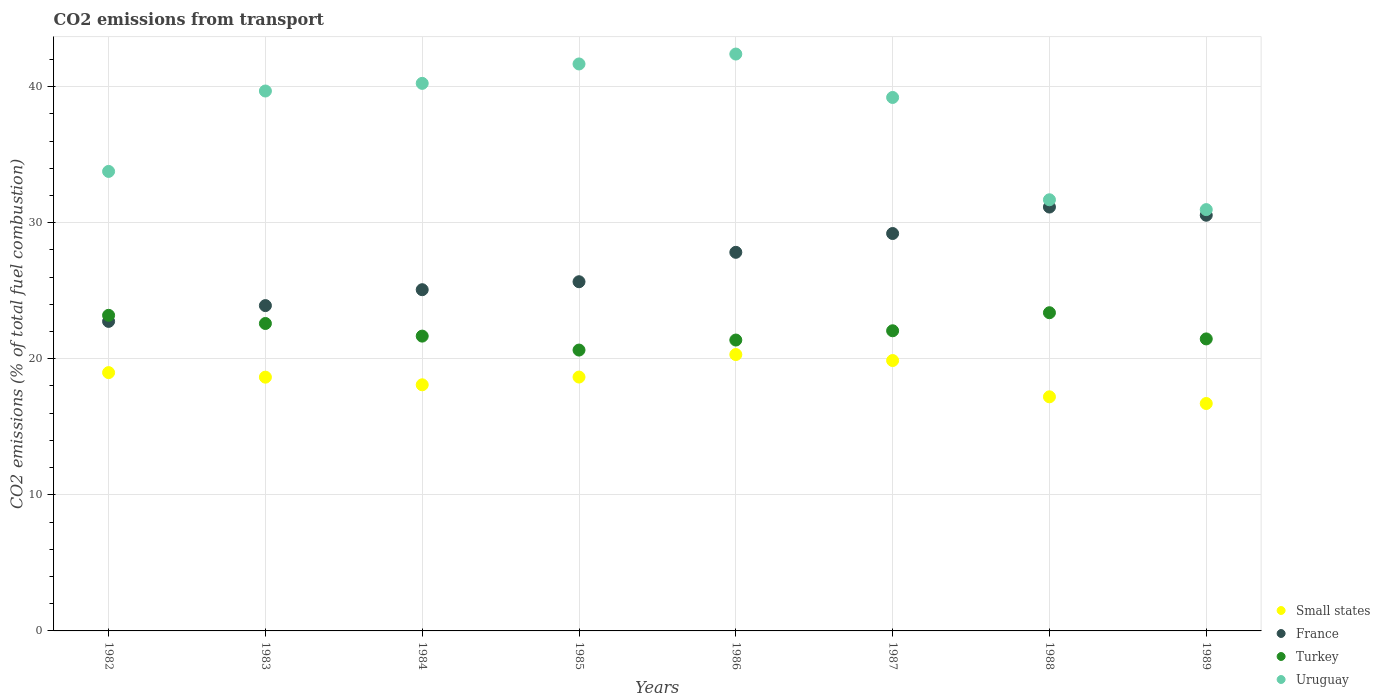Is the number of dotlines equal to the number of legend labels?
Your answer should be very brief. Yes. What is the total CO2 emitted in France in 1985?
Your answer should be compact. 25.66. Across all years, what is the maximum total CO2 emitted in France?
Keep it short and to the point. 31.15. Across all years, what is the minimum total CO2 emitted in Turkey?
Give a very brief answer. 20.64. In which year was the total CO2 emitted in Turkey minimum?
Provide a succinct answer. 1985. What is the total total CO2 emitted in France in the graph?
Your answer should be very brief. 216.12. What is the difference between the total CO2 emitted in Turkey in 1986 and that in 1988?
Make the answer very short. -2.01. What is the difference between the total CO2 emitted in Small states in 1984 and the total CO2 emitted in France in 1982?
Ensure brevity in your answer.  -4.66. What is the average total CO2 emitted in France per year?
Your answer should be compact. 27.02. In the year 1983, what is the difference between the total CO2 emitted in Small states and total CO2 emitted in France?
Offer a very short reply. -5.26. In how many years, is the total CO2 emitted in France greater than 4?
Give a very brief answer. 8. What is the ratio of the total CO2 emitted in France in 1986 to that in 1988?
Give a very brief answer. 0.89. Is the difference between the total CO2 emitted in Small states in 1983 and 1984 greater than the difference between the total CO2 emitted in France in 1983 and 1984?
Your answer should be compact. Yes. What is the difference between the highest and the second highest total CO2 emitted in Uruguay?
Offer a terse response. 0.73. What is the difference between the highest and the lowest total CO2 emitted in Small states?
Offer a terse response. 3.6. Does the total CO2 emitted in Turkey monotonically increase over the years?
Your answer should be very brief. No. Is the total CO2 emitted in Small states strictly greater than the total CO2 emitted in France over the years?
Keep it short and to the point. No. Is the total CO2 emitted in France strictly less than the total CO2 emitted in Turkey over the years?
Keep it short and to the point. No. How many dotlines are there?
Your response must be concise. 4. How many years are there in the graph?
Provide a short and direct response. 8. What is the difference between two consecutive major ticks on the Y-axis?
Provide a succinct answer. 10. Does the graph contain grids?
Make the answer very short. Yes. What is the title of the graph?
Offer a very short reply. CO2 emissions from transport. Does "Finland" appear as one of the legend labels in the graph?
Provide a succinct answer. No. What is the label or title of the X-axis?
Give a very brief answer. Years. What is the label or title of the Y-axis?
Your answer should be compact. CO2 emissions (% of total fuel combustion). What is the CO2 emissions (% of total fuel combustion) in Small states in 1982?
Your response must be concise. 18.98. What is the CO2 emissions (% of total fuel combustion) in France in 1982?
Make the answer very short. 22.75. What is the CO2 emissions (% of total fuel combustion) of Turkey in 1982?
Offer a very short reply. 23.19. What is the CO2 emissions (% of total fuel combustion) in Uruguay in 1982?
Your response must be concise. 33.77. What is the CO2 emissions (% of total fuel combustion) in Small states in 1983?
Ensure brevity in your answer.  18.65. What is the CO2 emissions (% of total fuel combustion) of France in 1983?
Offer a terse response. 23.91. What is the CO2 emissions (% of total fuel combustion) of Turkey in 1983?
Offer a terse response. 22.59. What is the CO2 emissions (% of total fuel combustion) of Uruguay in 1983?
Your response must be concise. 39.68. What is the CO2 emissions (% of total fuel combustion) in Small states in 1984?
Keep it short and to the point. 18.09. What is the CO2 emissions (% of total fuel combustion) in France in 1984?
Offer a very short reply. 25.08. What is the CO2 emissions (% of total fuel combustion) in Turkey in 1984?
Your response must be concise. 21.67. What is the CO2 emissions (% of total fuel combustion) of Uruguay in 1984?
Provide a succinct answer. 40.24. What is the CO2 emissions (% of total fuel combustion) of Small states in 1985?
Provide a short and direct response. 18.66. What is the CO2 emissions (% of total fuel combustion) of France in 1985?
Give a very brief answer. 25.66. What is the CO2 emissions (% of total fuel combustion) in Turkey in 1985?
Give a very brief answer. 20.64. What is the CO2 emissions (% of total fuel combustion) of Uruguay in 1985?
Your answer should be compact. 41.67. What is the CO2 emissions (% of total fuel combustion) of Small states in 1986?
Keep it short and to the point. 20.31. What is the CO2 emissions (% of total fuel combustion) in France in 1986?
Provide a short and direct response. 27.82. What is the CO2 emissions (% of total fuel combustion) in Turkey in 1986?
Offer a very short reply. 21.38. What is the CO2 emissions (% of total fuel combustion) of Uruguay in 1986?
Offer a terse response. 42.39. What is the CO2 emissions (% of total fuel combustion) in Small states in 1987?
Make the answer very short. 19.87. What is the CO2 emissions (% of total fuel combustion) in France in 1987?
Provide a succinct answer. 29.21. What is the CO2 emissions (% of total fuel combustion) in Turkey in 1987?
Make the answer very short. 22.06. What is the CO2 emissions (% of total fuel combustion) of Uruguay in 1987?
Give a very brief answer. 39.2. What is the CO2 emissions (% of total fuel combustion) of Small states in 1988?
Offer a terse response. 17.2. What is the CO2 emissions (% of total fuel combustion) of France in 1988?
Offer a very short reply. 31.15. What is the CO2 emissions (% of total fuel combustion) of Turkey in 1988?
Provide a short and direct response. 23.38. What is the CO2 emissions (% of total fuel combustion) in Uruguay in 1988?
Make the answer very short. 31.69. What is the CO2 emissions (% of total fuel combustion) in Small states in 1989?
Offer a very short reply. 16.71. What is the CO2 emissions (% of total fuel combustion) in France in 1989?
Your answer should be very brief. 30.55. What is the CO2 emissions (% of total fuel combustion) of Turkey in 1989?
Give a very brief answer. 21.46. What is the CO2 emissions (% of total fuel combustion) of Uruguay in 1989?
Give a very brief answer. 30.96. Across all years, what is the maximum CO2 emissions (% of total fuel combustion) of Small states?
Give a very brief answer. 20.31. Across all years, what is the maximum CO2 emissions (% of total fuel combustion) in France?
Your answer should be compact. 31.15. Across all years, what is the maximum CO2 emissions (% of total fuel combustion) of Turkey?
Provide a short and direct response. 23.38. Across all years, what is the maximum CO2 emissions (% of total fuel combustion) of Uruguay?
Give a very brief answer. 42.39. Across all years, what is the minimum CO2 emissions (% of total fuel combustion) of Small states?
Provide a short and direct response. 16.71. Across all years, what is the minimum CO2 emissions (% of total fuel combustion) of France?
Ensure brevity in your answer.  22.75. Across all years, what is the minimum CO2 emissions (% of total fuel combustion) of Turkey?
Your answer should be very brief. 20.64. Across all years, what is the minimum CO2 emissions (% of total fuel combustion) in Uruguay?
Keep it short and to the point. 30.96. What is the total CO2 emissions (% of total fuel combustion) of Small states in the graph?
Make the answer very short. 148.47. What is the total CO2 emissions (% of total fuel combustion) in France in the graph?
Ensure brevity in your answer.  216.12. What is the total CO2 emissions (% of total fuel combustion) in Turkey in the graph?
Make the answer very short. 176.37. What is the total CO2 emissions (% of total fuel combustion) of Uruguay in the graph?
Keep it short and to the point. 299.6. What is the difference between the CO2 emissions (% of total fuel combustion) of Small states in 1982 and that in 1983?
Your answer should be very brief. 0.33. What is the difference between the CO2 emissions (% of total fuel combustion) in France in 1982 and that in 1983?
Offer a very short reply. -1.16. What is the difference between the CO2 emissions (% of total fuel combustion) of Turkey in 1982 and that in 1983?
Give a very brief answer. 0.6. What is the difference between the CO2 emissions (% of total fuel combustion) in Uruguay in 1982 and that in 1983?
Offer a terse response. -5.91. What is the difference between the CO2 emissions (% of total fuel combustion) in Small states in 1982 and that in 1984?
Your answer should be compact. 0.9. What is the difference between the CO2 emissions (% of total fuel combustion) of France in 1982 and that in 1984?
Provide a short and direct response. -2.33. What is the difference between the CO2 emissions (% of total fuel combustion) in Turkey in 1982 and that in 1984?
Offer a very short reply. 1.53. What is the difference between the CO2 emissions (% of total fuel combustion) of Uruguay in 1982 and that in 1984?
Your answer should be very brief. -6.47. What is the difference between the CO2 emissions (% of total fuel combustion) in Small states in 1982 and that in 1985?
Provide a succinct answer. 0.33. What is the difference between the CO2 emissions (% of total fuel combustion) of France in 1982 and that in 1985?
Your answer should be compact. -2.91. What is the difference between the CO2 emissions (% of total fuel combustion) in Turkey in 1982 and that in 1985?
Keep it short and to the point. 2.55. What is the difference between the CO2 emissions (% of total fuel combustion) in Uruguay in 1982 and that in 1985?
Your answer should be compact. -7.9. What is the difference between the CO2 emissions (% of total fuel combustion) of Small states in 1982 and that in 1986?
Provide a short and direct response. -1.33. What is the difference between the CO2 emissions (% of total fuel combustion) in France in 1982 and that in 1986?
Provide a succinct answer. -5.08. What is the difference between the CO2 emissions (% of total fuel combustion) in Turkey in 1982 and that in 1986?
Your response must be concise. 1.82. What is the difference between the CO2 emissions (% of total fuel combustion) of Uruguay in 1982 and that in 1986?
Your answer should be compact. -8.63. What is the difference between the CO2 emissions (% of total fuel combustion) of Small states in 1982 and that in 1987?
Your answer should be very brief. -0.89. What is the difference between the CO2 emissions (% of total fuel combustion) of France in 1982 and that in 1987?
Give a very brief answer. -6.46. What is the difference between the CO2 emissions (% of total fuel combustion) of Turkey in 1982 and that in 1987?
Provide a short and direct response. 1.14. What is the difference between the CO2 emissions (% of total fuel combustion) in Uruguay in 1982 and that in 1987?
Your answer should be compact. -5.44. What is the difference between the CO2 emissions (% of total fuel combustion) in Small states in 1982 and that in 1988?
Keep it short and to the point. 1.78. What is the difference between the CO2 emissions (% of total fuel combustion) in France in 1982 and that in 1988?
Provide a succinct answer. -8.4. What is the difference between the CO2 emissions (% of total fuel combustion) of Turkey in 1982 and that in 1988?
Your answer should be compact. -0.19. What is the difference between the CO2 emissions (% of total fuel combustion) in Uruguay in 1982 and that in 1988?
Provide a short and direct response. 2.08. What is the difference between the CO2 emissions (% of total fuel combustion) of Small states in 1982 and that in 1989?
Keep it short and to the point. 2.27. What is the difference between the CO2 emissions (% of total fuel combustion) in France in 1982 and that in 1989?
Offer a very short reply. -7.8. What is the difference between the CO2 emissions (% of total fuel combustion) of Turkey in 1982 and that in 1989?
Provide a succinct answer. 1.73. What is the difference between the CO2 emissions (% of total fuel combustion) of Uruguay in 1982 and that in 1989?
Your response must be concise. 2.81. What is the difference between the CO2 emissions (% of total fuel combustion) in Small states in 1983 and that in 1984?
Provide a short and direct response. 0.56. What is the difference between the CO2 emissions (% of total fuel combustion) in France in 1983 and that in 1984?
Keep it short and to the point. -1.17. What is the difference between the CO2 emissions (% of total fuel combustion) of Turkey in 1983 and that in 1984?
Offer a very short reply. 0.93. What is the difference between the CO2 emissions (% of total fuel combustion) in Uruguay in 1983 and that in 1984?
Provide a succinct answer. -0.56. What is the difference between the CO2 emissions (% of total fuel combustion) in Small states in 1983 and that in 1985?
Offer a terse response. -0.01. What is the difference between the CO2 emissions (% of total fuel combustion) of France in 1983 and that in 1985?
Make the answer very short. -1.75. What is the difference between the CO2 emissions (% of total fuel combustion) of Turkey in 1983 and that in 1985?
Provide a succinct answer. 1.95. What is the difference between the CO2 emissions (% of total fuel combustion) in Uruguay in 1983 and that in 1985?
Your answer should be compact. -1.99. What is the difference between the CO2 emissions (% of total fuel combustion) in Small states in 1983 and that in 1986?
Offer a very short reply. -1.66. What is the difference between the CO2 emissions (% of total fuel combustion) of France in 1983 and that in 1986?
Keep it short and to the point. -3.92. What is the difference between the CO2 emissions (% of total fuel combustion) in Turkey in 1983 and that in 1986?
Ensure brevity in your answer.  1.22. What is the difference between the CO2 emissions (% of total fuel combustion) of Uruguay in 1983 and that in 1986?
Provide a succinct answer. -2.72. What is the difference between the CO2 emissions (% of total fuel combustion) in Small states in 1983 and that in 1987?
Your answer should be compact. -1.22. What is the difference between the CO2 emissions (% of total fuel combustion) in France in 1983 and that in 1987?
Keep it short and to the point. -5.3. What is the difference between the CO2 emissions (% of total fuel combustion) of Turkey in 1983 and that in 1987?
Make the answer very short. 0.54. What is the difference between the CO2 emissions (% of total fuel combustion) of Uruguay in 1983 and that in 1987?
Your answer should be compact. 0.47. What is the difference between the CO2 emissions (% of total fuel combustion) of Small states in 1983 and that in 1988?
Ensure brevity in your answer.  1.44. What is the difference between the CO2 emissions (% of total fuel combustion) of France in 1983 and that in 1988?
Give a very brief answer. -7.24. What is the difference between the CO2 emissions (% of total fuel combustion) of Turkey in 1983 and that in 1988?
Your response must be concise. -0.79. What is the difference between the CO2 emissions (% of total fuel combustion) in Uruguay in 1983 and that in 1988?
Provide a short and direct response. 7.99. What is the difference between the CO2 emissions (% of total fuel combustion) of Small states in 1983 and that in 1989?
Your answer should be very brief. 1.94. What is the difference between the CO2 emissions (% of total fuel combustion) of France in 1983 and that in 1989?
Provide a short and direct response. -6.64. What is the difference between the CO2 emissions (% of total fuel combustion) of Turkey in 1983 and that in 1989?
Give a very brief answer. 1.13. What is the difference between the CO2 emissions (% of total fuel combustion) in Uruguay in 1983 and that in 1989?
Offer a very short reply. 8.72. What is the difference between the CO2 emissions (% of total fuel combustion) of Small states in 1984 and that in 1985?
Provide a short and direct response. -0.57. What is the difference between the CO2 emissions (% of total fuel combustion) of France in 1984 and that in 1985?
Keep it short and to the point. -0.59. What is the difference between the CO2 emissions (% of total fuel combustion) in Turkey in 1984 and that in 1985?
Provide a short and direct response. 1.03. What is the difference between the CO2 emissions (% of total fuel combustion) of Uruguay in 1984 and that in 1985?
Ensure brevity in your answer.  -1.43. What is the difference between the CO2 emissions (% of total fuel combustion) in Small states in 1984 and that in 1986?
Your answer should be very brief. -2.22. What is the difference between the CO2 emissions (% of total fuel combustion) in France in 1984 and that in 1986?
Your answer should be very brief. -2.75. What is the difference between the CO2 emissions (% of total fuel combustion) of Turkey in 1984 and that in 1986?
Ensure brevity in your answer.  0.29. What is the difference between the CO2 emissions (% of total fuel combustion) in Uruguay in 1984 and that in 1986?
Offer a very short reply. -2.15. What is the difference between the CO2 emissions (% of total fuel combustion) in Small states in 1984 and that in 1987?
Offer a terse response. -1.78. What is the difference between the CO2 emissions (% of total fuel combustion) in France in 1984 and that in 1987?
Your answer should be very brief. -4.13. What is the difference between the CO2 emissions (% of total fuel combustion) in Turkey in 1984 and that in 1987?
Provide a succinct answer. -0.39. What is the difference between the CO2 emissions (% of total fuel combustion) in Uruguay in 1984 and that in 1987?
Provide a short and direct response. 1.04. What is the difference between the CO2 emissions (% of total fuel combustion) of Small states in 1984 and that in 1988?
Keep it short and to the point. 0.88. What is the difference between the CO2 emissions (% of total fuel combustion) of France in 1984 and that in 1988?
Offer a terse response. -6.07. What is the difference between the CO2 emissions (% of total fuel combustion) in Turkey in 1984 and that in 1988?
Offer a terse response. -1.72. What is the difference between the CO2 emissions (% of total fuel combustion) in Uruguay in 1984 and that in 1988?
Your answer should be very brief. 8.55. What is the difference between the CO2 emissions (% of total fuel combustion) of Small states in 1984 and that in 1989?
Your answer should be compact. 1.37. What is the difference between the CO2 emissions (% of total fuel combustion) of France in 1984 and that in 1989?
Give a very brief answer. -5.47. What is the difference between the CO2 emissions (% of total fuel combustion) of Turkey in 1984 and that in 1989?
Keep it short and to the point. 0.21. What is the difference between the CO2 emissions (% of total fuel combustion) in Uruguay in 1984 and that in 1989?
Your answer should be very brief. 9.28. What is the difference between the CO2 emissions (% of total fuel combustion) of Small states in 1985 and that in 1986?
Your response must be concise. -1.65. What is the difference between the CO2 emissions (% of total fuel combustion) of France in 1985 and that in 1986?
Provide a short and direct response. -2.16. What is the difference between the CO2 emissions (% of total fuel combustion) of Turkey in 1985 and that in 1986?
Ensure brevity in your answer.  -0.74. What is the difference between the CO2 emissions (% of total fuel combustion) of Uruguay in 1985 and that in 1986?
Your answer should be very brief. -0.73. What is the difference between the CO2 emissions (% of total fuel combustion) of Small states in 1985 and that in 1987?
Ensure brevity in your answer.  -1.21. What is the difference between the CO2 emissions (% of total fuel combustion) of France in 1985 and that in 1987?
Provide a succinct answer. -3.54. What is the difference between the CO2 emissions (% of total fuel combustion) in Turkey in 1985 and that in 1987?
Ensure brevity in your answer.  -1.42. What is the difference between the CO2 emissions (% of total fuel combustion) in Uruguay in 1985 and that in 1987?
Give a very brief answer. 2.46. What is the difference between the CO2 emissions (% of total fuel combustion) of Small states in 1985 and that in 1988?
Give a very brief answer. 1.45. What is the difference between the CO2 emissions (% of total fuel combustion) of France in 1985 and that in 1988?
Provide a succinct answer. -5.49. What is the difference between the CO2 emissions (% of total fuel combustion) in Turkey in 1985 and that in 1988?
Provide a succinct answer. -2.74. What is the difference between the CO2 emissions (% of total fuel combustion) of Uruguay in 1985 and that in 1988?
Offer a very short reply. 9.98. What is the difference between the CO2 emissions (% of total fuel combustion) in Small states in 1985 and that in 1989?
Give a very brief answer. 1.94. What is the difference between the CO2 emissions (% of total fuel combustion) of France in 1985 and that in 1989?
Give a very brief answer. -4.89. What is the difference between the CO2 emissions (% of total fuel combustion) of Turkey in 1985 and that in 1989?
Keep it short and to the point. -0.82. What is the difference between the CO2 emissions (% of total fuel combustion) in Uruguay in 1985 and that in 1989?
Ensure brevity in your answer.  10.7. What is the difference between the CO2 emissions (% of total fuel combustion) in Small states in 1986 and that in 1987?
Your answer should be very brief. 0.44. What is the difference between the CO2 emissions (% of total fuel combustion) of France in 1986 and that in 1987?
Ensure brevity in your answer.  -1.38. What is the difference between the CO2 emissions (% of total fuel combustion) of Turkey in 1986 and that in 1987?
Provide a succinct answer. -0.68. What is the difference between the CO2 emissions (% of total fuel combustion) in Uruguay in 1986 and that in 1987?
Provide a short and direct response. 3.19. What is the difference between the CO2 emissions (% of total fuel combustion) in Small states in 1986 and that in 1988?
Offer a terse response. 3.11. What is the difference between the CO2 emissions (% of total fuel combustion) of France in 1986 and that in 1988?
Your response must be concise. -3.33. What is the difference between the CO2 emissions (% of total fuel combustion) of Turkey in 1986 and that in 1988?
Keep it short and to the point. -2.01. What is the difference between the CO2 emissions (% of total fuel combustion) in Uruguay in 1986 and that in 1988?
Ensure brevity in your answer.  10.71. What is the difference between the CO2 emissions (% of total fuel combustion) in Small states in 1986 and that in 1989?
Ensure brevity in your answer.  3.6. What is the difference between the CO2 emissions (% of total fuel combustion) in France in 1986 and that in 1989?
Your response must be concise. -2.73. What is the difference between the CO2 emissions (% of total fuel combustion) in Turkey in 1986 and that in 1989?
Offer a very short reply. -0.08. What is the difference between the CO2 emissions (% of total fuel combustion) of Uruguay in 1986 and that in 1989?
Your answer should be compact. 11.43. What is the difference between the CO2 emissions (% of total fuel combustion) in Small states in 1987 and that in 1988?
Keep it short and to the point. 2.67. What is the difference between the CO2 emissions (% of total fuel combustion) of France in 1987 and that in 1988?
Keep it short and to the point. -1.94. What is the difference between the CO2 emissions (% of total fuel combustion) in Turkey in 1987 and that in 1988?
Provide a succinct answer. -1.33. What is the difference between the CO2 emissions (% of total fuel combustion) of Uruguay in 1987 and that in 1988?
Offer a very short reply. 7.52. What is the difference between the CO2 emissions (% of total fuel combustion) of Small states in 1987 and that in 1989?
Your response must be concise. 3.16. What is the difference between the CO2 emissions (% of total fuel combustion) in France in 1987 and that in 1989?
Offer a terse response. -1.34. What is the difference between the CO2 emissions (% of total fuel combustion) in Turkey in 1987 and that in 1989?
Offer a terse response. 0.6. What is the difference between the CO2 emissions (% of total fuel combustion) of Uruguay in 1987 and that in 1989?
Ensure brevity in your answer.  8.24. What is the difference between the CO2 emissions (% of total fuel combustion) in Small states in 1988 and that in 1989?
Offer a very short reply. 0.49. What is the difference between the CO2 emissions (% of total fuel combustion) of France in 1988 and that in 1989?
Offer a very short reply. 0.6. What is the difference between the CO2 emissions (% of total fuel combustion) of Turkey in 1988 and that in 1989?
Ensure brevity in your answer.  1.92. What is the difference between the CO2 emissions (% of total fuel combustion) of Uruguay in 1988 and that in 1989?
Provide a succinct answer. 0.72. What is the difference between the CO2 emissions (% of total fuel combustion) in Small states in 1982 and the CO2 emissions (% of total fuel combustion) in France in 1983?
Your answer should be very brief. -4.92. What is the difference between the CO2 emissions (% of total fuel combustion) in Small states in 1982 and the CO2 emissions (% of total fuel combustion) in Turkey in 1983?
Give a very brief answer. -3.61. What is the difference between the CO2 emissions (% of total fuel combustion) in Small states in 1982 and the CO2 emissions (% of total fuel combustion) in Uruguay in 1983?
Provide a succinct answer. -20.7. What is the difference between the CO2 emissions (% of total fuel combustion) of France in 1982 and the CO2 emissions (% of total fuel combustion) of Turkey in 1983?
Make the answer very short. 0.15. What is the difference between the CO2 emissions (% of total fuel combustion) in France in 1982 and the CO2 emissions (% of total fuel combustion) in Uruguay in 1983?
Make the answer very short. -16.93. What is the difference between the CO2 emissions (% of total fuel combustion) of Turkey in 1982 and the CO2 emissions (% of total fuel combustion) of Uruguay in 1983?
Your response must be concise. -16.48. What is the difference between the CO2 emissions (% of total fuel combustion) of Small states in 1982 and the CO2 emissions (% of total fuel combustion) of France in 1984?
Provide a succinct answer. -6.09. What is the difference between the CO2 emissions (% of total fuel combustion) of Small states in 1982 and the CO2 emissions (% of total fuel combustion) of Turkey in 1984?
Your answer should be compact. -2.68. What is the difference between the CO2 emissions (% of total fuel combustion) in Small states in 1982 and the CO2 emissions (% of total fuel combustion) in Uruguay in 1984?
Provide a succinct answer. -21.26. What is the difference between the CO2 emissions (% of total fuel combustion) of France in 1982 and the CO2 emissions (% of total fuel combustion) of Turkey in 1984?
Your response must be concise. 1.08. What is the difference between the CO2 emissions (% of total fuel combustion) in France in 1982 and the CO2 emissions (% of total fuel combustion) in Uruguay in 1984?
Offer a very short reply. -17.49. What is the difference between the CO2 emissions (% of total fuel combustion) of Turkey in 1982 and the CO2 emissions (% of total fuel combustion) of Uruguay in 1984?
Ensure brevity in your answer.  -17.05. What is the difference between the CO2 emissions (% of total fuel combustion) of Small states in 1982 and the CO2 emissions (% of total fuel combustion) of France in 1985?
Your answer should be compact. -6.68. What is the difference between the CO2 emissions (% of total fuel combustion) in Small states in 1982 and the CO2 emissions (% of total fuel combustion) in Turkey in 1985?
Your response must be concise. -1.66. What is the difference between the CO2 emissions (% of total fuel combustion) in Small states in 1982 and the CO2 emissions (% of total fuel combustion) in Uruguay in 1985?
Offer a terse response. -22.68. What is the difference between the CO2 emissions (% of total fuel combustion) of France in 1982 and the CO2 emissions (% of total fuel combustion) of Turkey in 1985?
Your answer should be very brief. 2.11. What is the difference between the CO2 emissions (% of total fuel combustion) in France in 1982 and the CO2 emissions (% of total fuel combustion) in Uruguay in 1985?
Keep it short and to the point. -18.92. What is the difference between the CO2 emissions (% of total fuel combustion) of Turkey in 1982 and the CO2 emissions (% of total fuel combustion) of Uruguay in 1985?
Offer a terse response. -18.47. What is the difference between the CO2 emissions (% of total fuel combustion) in Small states in 1982 and the CO2 emissions (% of total fuel combustion) in France in 1986?
Ensure brevity in your answer.  -8.84. What is the difference between the CO2 emissions (% of total fuel combustion) in Small states in 1982 and the CO2 emissions (% of total fuel combustion) in Turkey in 1986?
Make the answer very short. -2.39. What is the difference between the CO2 emissions (% of total fuel combustion) in Small states in 1982 and the CO2 emissions (% of total fuel combustion) in Uruguay in 1986?
Keep it short and to the point. -23.41. What is the difference between the CO2 emissions (% of total fuel combustion) in France in 1982 and the CO2 emissions (% of total fuel combustion) in Turkey in 1986?
Your answer should be very brief. 1.37. What is the difference between the CO2 emissions (% of total fuel combustion) of France in 1982 and the CO2 emissions (% of total fuel combustion) of Uruguay in 1986?
Provide a short and direct response. -19.65. What is the difference between the CO2 emissions (% of total fuel combustion) of Turkey in 1982 and the CO2 emissions (% of total fuel combustion) of Uruguay in 1986?
Give a very brief answer. -19.2. What is the difference between the CO2 emissions (% of total fuel combustion) of Small states in 1982 and the CO2 emissions (% of total fuel combustion) of France in 1987?
Offer a very short reply. -10.22. What is the difference between the CO2 emissions (% of total fuel combustion) of Small states in 1982 and the CO2 emissions (% of total fuel combustion) of Turkey in 1987?
Provide a succinct answer. -3.07. What is the difference between the CO2 emissions (% of total fuel combustion) of Small states in 1982 and the CO2 emissions (% of total fuel combustion) of Uruguay in 1987?
Keep it short and to the point. -20.22. What is the difference between the CO2 emissions (% of total fuel combustion) in France in 1982 and the CO2 emissions (% of total fuel combustion) in Turkey in 1987?
Your answer should be compact. 0.69. What is the difference between the CO2 emissions (% of total fuel combustion) in France in 1982 and the CO2 emissions (% of total fuel combustion) in Uruguay in 1987?
Ensure brevity in your answer.  -16.46. What is the difference between the CO2 emissions (% of total fuel combustion) of Turkey in 1982 and the CO2 emissions (% of total fuel combustion) of Uruguay in 1987?
Ensure brevity in your answer.  -16.01. What is the difference between the CO2 emissions (% of total fuel combustion) in Small states in 1982 and the CO2 emissions (% of total fuel combustion) in France in 1988?
Give a very brief answer. -12.17. What is the difference between the CO2 emissions (% of total fuel combustion) in Small states in 1982 and the CO2 emissions (% of total fuel combustion) in Turkey in 1988?
Provide a short and direct response. -4.4. What is the difference between the CO2 emissions (% of total fuel combustion) of Small states in 1982 and the CO2 emissions (% of total fuel combustion) of Uruguay in 1988?
Ensure brevity in your answer.  -12.7. What is the difference between the CO2 emissions (% of total fuel combustion) of France in 1982 and the CO2 emissions (% of total fuel combustion) of Turkey in 1988?
Your answer should be compact. -0.64. What is the difference between the CO2 emissions (% of total fuel combustion) of France in 1982 and the CO2 emissions (% of total fuel combustion) of Uruguay in 1988?
Offer a terse response. -8.94. What is the difference between the CO2 emissions (% of total fuel combustion) in Turkey in 1982 and the CO2 emissions (% of total fuel combustion) in Uruguay in 1988?
Offer a terse response. -8.49. What is the difference between the CO2 emissions (% of total fuel combustion) in Small states in 1982 and the CO2 emissions (% of total fuel combustion) in France in 1989?
Your answer should be compact. -11.57. What is the difference between the CO2 emissions (% of total fuel combustion) in Small states in 1982 and the CO2 emissions (% of total fuel combustion) in Turkey in 1989?
Provide a succinct answer. -2.48. What is the difference between the CO2 emissions (% of total fuel combustion) of Small states in 1982 and the CO2 emissions (% of total fuel combustion) of Uruguay in 1989?
Offer a very short reply. -11.98. What is the difference between the CO2 emissions (% of total fuel combustion) in France in 1982 and the CO2 emissions (% of total fuel combustion) in Turkey in 1989?
Your answer should be compact. 1.29. What is the difference between the CO2 emissions (% of total fuel combustion) of France in 1982 and the CO2 emissions (% of total fuel combustion) of Uruguay in 1989?
Offer a terse response. -8.21. What is the difference between the CO2 emissions (% of total fuel combustion) of Turkey in 1982 and the CO2 emissions (% of total fuel combustion) of Uruguay in 1989?
Give a very brief answer. -7.77. What is the difference between the CO2 emissions (% of total fuel combustion) in Small states in 1983 and the CO2 emissions (% of total fuel combustion) in France in 1984?
Provide a succinct answer. -6.43. What is the difference between the CO2 emissions (% of total fuel combustion) in Small states in 1983 and the CO2 emissions (% of total fuel combustion) in Turkey in 1984?
Provide a short and direct response. -3.02. What is the difference between the CO2 emissions (% of total fuel combustion) in Small states in 1983 and the CO2 emissions (% of total fuel combustion) in Uruguay in 1984?
Offer a terse response. -21.59. What is the difference between the CO2 emissions (% of total fuel combustion) in France in 1983 and the CO2 emissions (% of total fuel combustion) in Turkey in 1984?
Provide a succinct answer. 2.24. What is the difference between the CO2 emissions (% of total fuel combustion) of France in 1983 and the CO2 emissions (% of total fuel combustion) of Uruguay in 1984?
Provide a short and direct response. -16.33. What is the difference between the CO2 emissions (% of total fuel combustion) of Turkey in 1983 and the CO2 emissions (% of total fuel combustion) of Uruguay in 1984?
Provide a short and direct response. -17.65. What is the difference between the CO2 emissions (% of total fuel combustion) of Small states in 1983 and the CO2 emissions (% of total fuel combustion) of France in 1985?
Provide a short and direct response. -7.01. What is the difference between the CO2 emissions (% of total fuel combustion) in Small states in 1983 and the CO2 emissions (% of total fuel combustion) in Turkey in 1985?
Provide a short and direct response. -1.99. What is the difference between the CO2 emissions (% of total fuel combustion) in Small states in 1983 and the CO2 emissions (% of total fuel combustion) in Uruguay in 1985?
Provide a short and direct response. -23.02. What is the difference between the CO2 emissions (% of total fuel combustion) in France in 1983 and the CO2 emissions (% of total fuel combustion) in Turkey in 1985?
Give a very brief answer. 3.27. What is the difference between the CO2 emissions (% of total fuel combustion) in France in 1983 and the CO2 emissions (% of total fuel combustion) in Uruguay in 1985?
Your response must be concise. -17.76. What is the difference between the CO2 emissions (% of total fuel combustion) of Turkey in 1983 and the CO2 emissions (% of total fuel combustion) of Uruguay in 1985?
Your answer should be very brief. -19.07. What is the difference between the CO2 emissions (% of total fuel combustion) of Small states in 1983 and the CO2 emissions (% of total fuel combustion) of France in 1986?
Your answer should be compact. -9.18. What is the difference between the CO2 emissions (% of total fuel combustion) in Small states in 1983 and the CO2 emissions (% of total fuel combustion) in Turkey in 1986?
Offer a terse response. -2.73. What is the difference between the CO2 emissions (% of total fuel combustion) in Small states in 1983 and the CO2 emissions (% of total fuel combustion) in Uruguay in 1986?
Your answer should be very brief. -23.75. What is the difference between the CO2 emissions (% of total fuel combustion) in France in 1983 and the CO2 emissions (% of total fuel combustion) in Turkey in 1986?
Give a very brief answer. 2.53. What is the difference between the CO2 emissions (% of total fuel combustion) of France in 1983 and the CO2 emissions (% of total fuel combustion) of Uruguay in 1986?
Offer a terse response. -18.49. What is the difference between the CO2 emissions (% of total fuel combustion) in Turkey in 1983 and the CO2 emissions (% of total fuel combustion) in Uruguay in 1986?
Your response must be concise. -19.8. What is the difference between the CO2 emissions (% of total fuel combustion) of Small states in 1983 and the CO2 emissions (% of total fuel combustion) of France in 1987?
Offer a very short reply. -10.56. What is the difference between the CO2 emissions (% of total fuel combustion) in Small states in 1983 and the CO2 emissions (% of total fuel combustion) in Turkey in 1987?
Give a very brief answer. -3.41. What is the difference between the CO2 emissions (% of total fuel combustion) of Small states in 1983 and the CO2 emissions (% of total fuel combustion) of Uruguay in 1987?
Your answer should be compact. -20.56. What is the difference between the CO2 emissions (% of total fuel combustion) in France in 1983 and the CO2 emissions (% of total fuel combustion) in Turkey in 1987?
Offer a very short reply. 1.85. What is the difference between the CO2 emissions (% of total fuel combustion) of France in 1983 and the CO2 emissions (% of total fuel combustion) of Uruguay in 1987?
Your response must be concise. -15.3. What is the difference between the CO2 emissions (% of total fuel combustion) of Turkey in 1983 and the CO2 emissions (% of total fuel combustion) of Uruguay in 1987?
Offer a very short reply. -16.61. What is the difference between the CO2 emissions (% of total fuel combustion) in Small states in 1983 and the CO2 emissions (% of total fuel combustion) in France in 1988?
Offer a very short reply. -12.5. What is the difference between the CO2 emissions (% of total fuel combustion) of Small states in 1983 and the CO2 emissions (% of total fuel combustion) of Turkey in 1988?
Provide a short and direct response. -4.74. What is the difference between the CO2 emissions (% of total fuel combustion) in Small states in 1983 and the CO2 emissions (% of total fuel combustion) in Uruguay in 1988?
Ensure brevity in your answer.  -13.04. What is the difference between the CO2 emissions (% of total fuel combustion) in France in 1983 and the CO2 emissions (% of total fuel combustion) in Turkey in 1988?
Your answer should be compact. 0.52. What is the difference between the CO2 emissions (% of total fuel combustion) of France in 1983 and the CO2 emissions (% of total fuel combustion) of Uruguay in 1988?
Your answer should be very brief. -7.78. What is the difference between the CO2 emissions (% of total fuel combustion) in Turkey in 1983 and the CO2 emissions (% of total fuel combustion) in Uruguay in 1988?
Ensure brevity in your answer.  -9.09. What is the difference between the CO2 emissions (% of total fuel combustion) of Small states in 1983 and the CO2 emissions (% of total fuel combustion) of France in 1989?
Keep it short and to the point. -11.9. What is the difference between the CO2 emissions (% of total fuel combustion) in Small states in 1983 and the CO2 emissions (% of total fuel combustion) in Turkey in 1989?
Keep it short and to the point. -2.81. What is the difference between the CO2 emissions (% of total fuel combustion) of Small states in 1983 and the CO2 emissions (% of total fuel combustion) of Uruguay in 1989?
Your answer should be compact. -12.31. What is the difference between the CO2 emissions (% of total fuel combustion) of France in 1983 and the CO2 emissions (% of total fuel combustion) of Turkey in 1989?
Offer a terse response. 2.45. What is the difference between the CO2 emissions (% of total fuel combustion) in France in 1983 and the CO2 emissions (% of total fuel combustion) in Uruguay in 1989?
Keep it short and to the point. -7.05. What is the difference between the CO2 emissions (% of total fuel combustion) in Turkey in 1983 and the CO2 emissions (% of total fuel combustion) in Uruguay in 1989?
Provide a succinct answer. -8.37. What is the difference between the CO2 emissions (% of total fuel combustion) in Small states in 1984 and the CO2 emissions (% of total fuel combustion) in France in 1985?
Offer a terse response. -7.57. What is the difference between the CO2 emissions (% of total fuel combustion) of Small states in 1984 and the CO2 emissions (% of total fuel combustion) of Turkey in 1985?
Ensure brevity in your answer.  -2.55. What is the difference between the CO2 emissions (% of total fuel combustion) in Small states in 1984 and the CO2 emissions (% of total fuel combustion) in Uruguay in 1985?
Offer a very short reply. -23.58. What is the difference between the CO2 emissions (% of total fuel combustion) of France in 1984 and the CO2 emissions (% of total fuel combustion) of Turkey in 1985?
Your response must be concise. 4.44. What is the difference between the CO2 emissions (% of total fuel combustion) of France in 1984 and the CO2 emissions (% of total fuel combustion) of Uruguay in 1985?
Keep it short and to the point. -16.59. What is the difference between the CO2 emissions (% of total fuel combustion) of Turkey in 1984 and the CO2 emissions (% of total fuel combustion) of Uruguay in 1985?
Keep it short and to the point. -20. What is the difference between the CO2 emissions (% of total fuel combustion) in Small states in 1984 and the CO2 emissions (% of total fuel combustion) in France in 1986?
Your response must be concise. -9.74. What is the difference between the CO2 emissions (% of total fuel combustion) of Small states in 1984 and the CO2 emissions (% of total fuel combustion) of Turkey in 1986?
Offer a terse response. -3.29. What is the difference between the CO2 emissions (% of total fuel combustion) in Small states in 1984 and the CO2 emissions (% of total fuel combustion) in Uruguay in 1986?
Keep it short and to the point. -24.31. What is the difference between the CO2 emissions (% of total fuel combustion) in France in 1984 and the CO2 emissions (% of total fuel combustion) in Turkey in 1986?
Offer a very short reply. 3.7. What is the difference between the CO2 emissions (% of total fuel combustion) of France in 1984 and the CO2 emissions (% of total fuel combustion) of Uruguay in 1986?
Offer a very short reply. -17.32. What is the difference between the CO2 emissions (% of total fuel combustion) of Turkey in 1984 and the CO2 emissions (% of total fuel combustion) of Uruguay in 1986?
Keep it short and to the point. -20.73. What is the difference between the CO2 emissions (% of total fuel combustion) in Small states in 1984 and the CO2 emissions (% of total fuel combustion) in France in 1987?
Offer a very short reply. -11.12. What is the difference between the CO2 emissions (% of total fuel combustion) of Small states in 1984 and the CO2 emissions (% of total fuel combustion) of Turkey in 1987?
Keep it short and to the point. -3.97. What is the difference between the CO2 emissions (% of total fuel combustion) of Small states in 1984 and the CO2 emissions (% of total fuel combustion) of Uruguay in 1987?
Ensure brevity in your answer.  -21.12. What is the difference between the CO2 emissions (% of total fuel combustion) in France in 1984 and the CO2 emissions (% of total fuel combustion) in Turkey in 1987?
Your answer should be compact. 3.02. What is the difference between the CO2 emissions (% of total fuel combustion) in France in 1984 and the CO2 emissions (% of total fuel combustion) in Uruguay in 1987?
Offer a very short reply. -14.13. What is the difference between the CO2 emissions (% of total fuel combustion) of Turkey in 1984 and the CO2 emissions (% of total fuel combustion) of Uruguay in 1987?
Keep it short and to the point. -17.54. What is the difference between the CO2 emissions (% of total fuel combustion) in Small states in 1984 and the CO2 emissions (% of total fuel combustion) in France in 1988?
Provide a succinct answer. -13.06. What is the difference between the CO2 emissions (% of total fuel combustion) in Small states in 1984 and the CO2 emissions (% of total fuel combustion) in Turkey in 1988?
Make the answer very short. -5.3. What is the difference between the CO2 emissions (% of total fuel combustion) in Small states in 1984 and the CO2 emissions (% of total fuel combustion) in Uruguay in 1988?
Ensure brevity in your answer.  -13.6. What is the difference between the CO2 emissions (% of total fuel combustion) in France in 1984 and the CO2 emissions (% of total fuel combustion) in Turkey in 1988?
Offer a very short reply. 1.69. What is the difference between the CO2 emissions (% of total fuel combustion) of France in 1984 and the CO2 emissions (% of total fuel combustion) of Uruguay in 1988?
Your response must be concise. -6.61. What is the difference between the CO2 emissions (% of total fuel combustion) in Turkey in 1984 and the CO2 emissions (% of total fuel combustion) in Uruguay in 1988?
Your answer should be very brief. -10.02. What is the difference between the CO2 emissions (% of total fuel combustion) in Small states in 1984 and the CO2 emissions (% of total fuel combustion) in France in 1989?
Your response must be concise. -12.46. What is the difference between the CO2 emissions (% of total fuel combustion) of Small states in 1984 and the CO2 emissions (% of total fuel combustion) of Turkey in 1989?
Make the answer very short. -3.37. What is the difference between the CO2 emissions (% of total fuel combustion) in Small states in 1984 and the CO2 emissions (% of total fuel combustion) in Uruguay in 1989?
Ensure brevity in your answer.  -12.87. What is the difference between the CO2 emissions (% of total fuel combustion) in France in 1984 and the CO2 emissions (% of total fuel combustion) in Turkey in 1989?
Offer a very short reply. 3.62. What is the difference between the CO2 emissions (% of total fuel combustion) in France in 1984 and the CO2 emissions (% of total fuel combustion) in Uruguay in 1989?
Provide a short and direct response. -5.89. What is the difference between the CO2 emissions (% of total fuel combustion) in Turkey in 1984 and the CO2 emissions (% of total fuel combustion) in Uruguay in 1989?
Give a very brief answer. -9.3. What is the difference between the CO2 emissions (% of total fuel combustion) of Small states in 1985 and the CO2 emissions (% of total fuel combustion) of France in 1986?
Offer a very short reply. -9.17. What is the difference between the CO2 emissions (% of total fuel combustion) of Small states in 1985 and the CO2 emissions (% of total fuel combustion) of Turkey in 1986?
Ensure brevity in your answer.  -2.72. What is the difference between the CO2 emissions (% of total fuel combustion) in Small states in 1985 and the CO2 emissions (% of total fuel combustion) in Uruguay in 1986?
Your answer should be very brief. -23.74. What is the difference between the CO2 emissions (% of total fuel combustion) in France in 1985 and the CO2 emissions (% of total fuel combustion) in Turkey in 1986?
Give a very brief answer. 4.28. What is the difference between the CO2 emissions (% of total fuel combustion) of France in 1985 and the CO2 emissions (% of total fuel combustion) of Uruguay in 1986?
Give a very brief answer. -16.73. What is the difference between the CO2 emissions (% of total fuel combustion) in Turkey in 1985 and the CO2 emissions (% of total fuel combustion) in Uruguay in 1986?
Give a very brief answer. -21.75. What is the difference between the CO2 emissions (% of total fuel combustion) in Small states in 1985 and the CO2 emissions (% of total fuel combustion) in France in 1987?
Ensure brevity in your answer.  -10.55. What is the difference between the CO2 emissions (% of total fuel combustion) of Small states in 1985 and the CO2 emissions (% of total fuel combustion) of Turkey in 1987?
Ensure brevity in your answer.  -3.4. What is the difference between the CO2 emissions (% of total fuel combustion) in Small states in 1985 and the CO2 emissions (% of total fuel combustion) in Uruguay in 1987?
Your answer should be very brief. -20.55. What is the difference between the CO2 emissions (% of total fuel combustion) in France in 1985 and the CO2 emissions (% of total fuel combustion) in Turkey in 1987?
Your answer should be compact. 3.6. What is the difference between the CO2 emissions (% of total fuel combustion) of France in 1985 and the CO2 emissions (% of total fuel combustion) of Uruguay in 1987?
Provide a short and direct response. -13.54. What is the difference between the CO2 emissions (% of total fuel combustion) in Turkey in 1985 and the CO2 emissions (% of total fuel combustion) in Uruguay in 1987?
Ensure brevity in your answer.  -18.56. What is the difference between the CO2 emissions (% of total fuel combustion) of Small states in 1985 and the CO2 emissions (% of total fuel combustion) of France in 1988?
Your response must be concise. -12.49. What is the difference between the CO2 emissions (% of total fuel combustion) in Small states in 1985 and the CO2 emissions (% of total fuel combustion) in Turkey in 1988?
Offer a terse response. -4.73. What is the difference between the CO2 emissions (% of total fuel combustion) in Small states in 1985 and the CO2 emissions (% of total fuel combustion) in Uruguay in 1988?
Ensure brevity in your answer.  -13.03. What is the difference between the CO2 emissions (% of total fuel combustion) in France in 1985 and the CO2 emissions (% of total fuel combustion) in Turkey in 1988?
Provide a short and direct response. 2.28. What is the difference between the CO2 emissions (% of total fuel combustion) of France in 1985 and the CO2 emissions (% of total fuel combustion) of Uruguay in 1988?
Offer a very short reply. -6.02. What is the difference between the CO2 emissions (% of total fuel combustion) of Turkey in 1985 and the CO2 emissions (% of total fuel combustion) of Uruguay in 1988?
Give a very brief answer. -11.04. What is the difference between the CO2 emissions (% of total fuel combustion) of Small states in 1985 and the CO2 emissions (% of total fuel combustion) of France in 1989?
Provide a short and direct response. -11.89. What is the difference between the CO2 emissions (% of total fuel combustion) of Small states in 1985 and the CO2 emissions (% of total fuel combustion) of Turkey in 1989?
Offer a very short reply. -2.8. What is the difference between the CO2 emissions (% of total fuel combustion) in Small states in 1985 and the CO2 emissions (% of total fuel combustion) in Uruguay in 1989?
Make the answer very short. -12.31. What is the difference between the CO2 emissions (% of total fuel combustion) in France in 1985 and the CO2 emissions (% of total fuel combustion) in Turkey in 1989?
Give a very brief answer. 4.2. What is the difference between the CO2 emissions (% of total fuel combustion) in France in 1985 and the CO2 emissions (% of total fuel combustion) in Uruguay in 1989?
Your answer should be very brief. -5.3. What is the difference between the CO2 emissions (% of total fuel combustion) in Turkey in 1985 and the CO2 emissions (% of total fuel combustion) in Uruguay in 1989?
Provide a succinct answer. -10.32. What is the difference between the CO2 emissions (% of total fuel combustion) of Small states in 1986 and the CO2 emissions (% of total fuel combustion) of France in 1987?
Ensure brevity in your answer.  -8.89. What is the difference between the CO2 emissions (% of total fuel combustion) of Small states in 1986 and the CO2 emissions (% of total fuel combustion) of Turkey in 1987?
Ensure brevity in your answer.  -1.75. What is the difference between the CO2 emissions (% of total fuel combustion) of Small states in 1986 and the CO2 emissions (% of total fuel combustion) of Uruguay in 1987?
Your response must be concise. -18.89. What is the difference between the CO2 emissions (% of total fuel combustion) in France in 1986 and the CO2 emissions (% of total fuel combustion) in Turkey in 1987?
Provide a short and direct response. 5.77. What is the difference between the CO2 emissions (% of total fuel combustion) of France in 1986 and the CO2 emissions (% of total fuel combustion) of Uruguay in 1987?
Make the answer very short. -11.38. What is the difference between the CO2 emissions (% of total fuel combustion) in Turkey in 1986 and the CO2 emissions (% of total fuel combustion) in Uruguay in 1987?
Your response must be concise. -17.83. What is the difference between the CO2 emissions (% of total fuel combustion) in Small states in 1986 and the CO2 emissions (% of total fuel combustion) in France in 1988?
Your answer should be compact. -10.84. What is the difference between the CO2 emissions (% of total fuel combustion) in Small states in 1986 and the CO2 emissions (% of total fuel combustion) in Turkey in 1988?
Your response must be concise. -3.07. What is the difference between the CO2 emissions (% of total fuel combustion) of Small states in 1986 and the CO2 emissions (% of total fuel combustion) of Uruguay in 1988?
Offer a terse response. -11.37. What is the difference between the CO2 emissions (% of total fuel combustion) of France in 1986 and the CO2 emissions (% of total fuel combustion) of Turkey in 1988?
Give a very brief answer. 4.44. What is the difference between the CO2 emissions (% of total fuel combustion) of France in 1986 and the CO2 emissions (% of total fuel combustion) of Uruguay in 1988?
Your response must be concise. -3.86. What is the difference between the CO2 emissions (% of total fuel combustion) of Turkey in 1986 and the CO2 emissions (% of total fuel combustion) of Uruguay in 1988?
Provide a short and direct response. -10.31. What is the difference between the CO2 emissions (% of total fuel combustion) of Small states in 1986 and the CO2 emissions (% of total fuel combustion) of France in 1989?
Your answer should be very brief. -10.24. What is the difference between the CO2 emissions (% of total fuel combustion) in Small states in 1986 and the CO2 emissions (% of total fuel combustion) in Turkey in 1989?
Your answer should be compact. -1.15. What is the difference between the CO2 emissions (% of total fuel combustion) of Small states in 1986 and the CO2 emissions (% of total fuel combustion) of Uruguay in 1989?
Ensure brevity in your answer.  -10.65. What is the difference between the CO2 emissions (% of total fuel combustion) in France in 1986 and the CO2 emissions (% of total fuel combustion) in Turkey in 1989?
Offer a terse response. 6.36. What is the difference between the CO2 emissions (% of total fuel combustion) of France in 1986 and the CO2 emissions (% of total fuel combustion) of Uruguay in 1989?
Your answer should be compact. -3.14. What is the difference between the CO2 emissions (% of total fuel combustion) of Turkey in 1986 and the CO2 emissions (% of total fuel combustion) of Uruguay in 1989?
Ensure brevity in your answer.  -9.59. What is the difference between the CO2 emissions (% of total fuel combustion) of Small states in 1987 and the CO2 emissions (% of total fuel combustion) of France in 1988?
Your answer should be compact. -11.28. What is the difference between the CO2 emissions (% of total fuel combustion) of Small states in 1987 and the CO2 emissions (% of total fuel combustion) of Turkey in 1988?
Make the answer very short. -3.51. What is the difference between the CO2 emissions (% of total fuel combustion) of Small states in 1987 and the CO2 emissions (% of total fuel combustion) of Uruguay in 1988?
Your answer should be very brief. -11.81. What is the difference between the CO2 emissions (% of total fuel combustion) of France in 1987 and the CO2 emissions (% of total fuel combustion) of Turkey in 1988?
Your answer should be very brief. 5.82. What is the difference between the CO2 emissions (% of total fuel combustion) in France in 1987 and the CO2 emissions (% of total fuel combustion) in Uruguay in 1988?
Offer a very short reply. -2.48. What is the difference between the CO2 emissions (% of total fuel combustion) of Turkey in 1987 and the CO2 emissions (% of total fuel combustion) of Uruguay in 1988?
Provide a succinct answer. -9.63. What is the difference between the CO2 emissions (% of total fuel combustion) in Small states in 1987 and the CO2 emissions (% of total fuel combustion) in France in 1989?
Make the answer very short. -10.68. What is the difference between the CO2 emissions (% of total fuel combustion) in Small states in 1987 and the CO2 emissions (% of total fuel combustion) in Turkey in 1989?
Keep it short and to the point. -1.59. What is the difference between the CO2 emissions (% of total fuel combustion) in Small states in 1987 and the CO2 emissions (% of total fuel combustion) in Uruguay in 1989?
Your answer should be compact. -11.09. What is the difference between the CO2 emissions (% of total fuel combustion) in France in 1987 and the CO2 emissions (% of total fuel combustion) in Turkey in 1989?
Keep it short and to the point. 7.75. What is the difference between the CO2 emissions (% of total fuel combustion) of France in 1987 and the CO2 emissions (% of total fuel combustion) of Uruguay in 1989?
Make the answer very short. -1.76. What is the difference between the CO2 emissions (% of total fuel combustion) of Turkey in 1987 and the CO2 emissions (% of total fuel combustion) of Uruguay in 1989?
Provide a succinct answer. -8.9. What is the difference between the CO2 emissions (% of total fuel combustion) in Small states in 1988 and the CO2 emissions (% of total fuel combustion) in France in 1989?
Your answer should be compact. -13.34. What is the difference between the CO2 emissions (% of total fuel combustion) of Small states in 1988 and the CO2 emissions (% of total fuel combustion) of Turkey in 1989?
Your answer should be very brief. -4.26. What is the difference between the CO2 emissions (% of total fuel combustion) in Small states in 1988 and the CO2 emissions (% of total fuel combustion) in Uruguay in 1989?
Make the answer very short. -13.76. What is the difference between the CO2 emissions (% of total fuel combustion) in France in 1988 and the CO2 emissions (% of total fuel combustion) in Turkey in 1989?
Provide a short and direct response. 9.69. What is the difference between the CO2 emissions (% of total fuel combustion) in France in 1988 and the CO2 emissions (% of total fuel combustion) in Uruguay in 1989?
Provide a succinct answer. 0.19. What is the difference between the CO2 emissions (% of total fuel combustion) in Turkey in 1988 and the CO2 emissions (% of total fuel combustion) in Uruguay in 1989?
Make the answer very short. -7.58. What is the average CO2 emissions (% of total fuel combustion) of Small states per year?
Provide a succinct answer. 18.56. What is the average CO2 emissions (% of total fuel combustion) in France per year?
Offer a terse response. 27.02. What is the average CO2 emissions (% of total fuel combustion) in Turkey per year?
Keep it short and to the point. 22.05. What is the average CO2 emissions (% of total fuel combustion) of Uruguay per year?
Your response must be concise. 37.45. In the year 1982, what is the difference between the CO2 emissions (% of total fuel combustion) of Small states and CO2 emissions (% of total fuel combustion) of France?
Offer a very short reply. -3.76. In the year 1982, what is the difference between the CO2 emissions (% of total fuel combustion) of Small states and CO2 emissions (% of total fuel combustion) of Turkey?
Provide a short and direct response. -4.21. In the year 1982, what is the difference between the CO2 emissions (% of total fuel combustion) of Small states and CO2 emissions (% of total fuel combustion) of Uruguay?
Your answer should be very brief. -14.79. In the year 1982, what is the difference between the CO2 emissions (% of total fuel combustion) in France and CO2 emissions (% of total fuel combustion) in Turkey?
Offer a terse response. -0.45. In the year 1982, what is the difference between the CO2 emissions (% of total fuel combustion) of France and CO2 emissions (% of total fuel combustion) of Uruguay?
Keep it short and to the point. -11.02. In the year 1982, what is the difference between the CO2 emissions (% of total fuel combustion) in Turkey and CO2 emissions (% of total fuel combustion) in Uruguay?
Your answer should be compact. -10.58. In the year 1983, what is the difference between the CO2 emissions (% of total fuel combustion) in Small states and CO2 emissions (% of total fuel combustion) in France?
Your response must be concise. -5.26. In the year 1983, what is the difference between the CO2 emissions (% of total fuel combustion) in Small states and CO2 emissions (% of total fuel combustion) in Turkey?
Provide a short and direct response. -3.94. In the year 1983, what is the difference between the CO2 emissions (% of total fuel combustion) in Small states and CO2 emissions (% of total fuel combustion) in Uruguay?
Your answer should be very brief. -21.03. In the year 1983, what is the difference between the CO2 emissions (% of total fuel combustion) of France and CO2 emissions (% of total fuel combustion) of Turkey?
Keep it short and to the point. 1.31. In the year 1983, what is the difference between the CO2 emissions (% of total fuel combustion) in France and CO2 emissions (% of total fuel combustion) in Uruguay?
Your answer should be compact. -15.77. In the year 1983, what is the difference between the CO2 emissions (% of total fuel combustion) in Turkey and CO2 emissions (% of total fuel combustion) in Uruguay?
Keep it short and to the point. -17.09. In the year 1984, what is the difference between the CO2 emissions (% of total fuel combustion) of Small states and CO2 emissions (% of total fuel combustion) of France?
Give a very brief answer. -6.99. In the year 1984, what is the difference between the CO2 emissions (% of total fuel combustion) in Small states and CO2 emissions (% of total fuel combustion) in Turkey?
Give a very brief answer. -3.58. In the year 1984, what is the difference between the CO2 emissions (% of total fuel combustion) in Small states and CO2 emissions (% of total fuel combustion) in Uruguay?
Keep it short and to the point. -22.15. In the year 1984, what is the difference between the CO2 emissions (% of total fuel combustion) in France and CO2 emissions (% of total fuel combustion) in Turkey?
Give a very brief answer. 3.41. In the year 1984, what is the difference between the CO2 emissions (% of total fuel combustion) in France and CO2 emissions (% of total fuel combustion) in Uruguay?
Make the answer very short. -15.16. In the year 1984, what is the difference between the CO2 emissions (% of total fuel combustion) in Turkey and CO2 emissions (% of total fuel combustion) in Uruguay?
Keep it short and to the point. -18.57. In the year 1985, what is the difference between the CO2 emissions (% of total fuel combustion) in Small states and CO2 emissions (% of total fuel combustion) in France?
Offer a very short reply. -7.01. In the year 1985, what is the difference between the CO2 emissions (% of total fuel combustion) in Small states and CO2 emissions (% of total fuel combustion) in Turkey?
Provide a short and direct response. -1.98. In the year 1985, what is the difference between the CO2 emissions (% of total fuel combustion) of Small states and CO2 emissions (% of total fuel combustion) of Uruguay?
Provide a short and direct response. -23.01. In the year 1985, what is the difference between the CO2 emissions (% of total fuel combustion) in France and CO2 emissions (% of total fuel combustion) in Turkey?
Offer a terse response. 5.02. In the year 1985, what is the difference between the CO2 emissions (% of total fuel combustion) of France and CO2 emissions (% of total fuel combustion) of Uruguay?
Give a very brief answer. -16. In the year 1985, what is the difference between the CO2 emissions (% of total fuel combustion) in Turkey and CO2 emissions (% of total fuel combustion) in Uruguay?
Give a very brief answer. -21.03. In the year 1986, what is the difference between the CO2 emissions (% of total fuel combustion) of Small states and CO2 emissions (% of total fuel combustion) of France?
Give a very brief answer. -7.51. In the year 1986, what is the difference between the CO2 emissions (% of total fuel combustion) of Small states and CO2 emissions (% of total fuel combustion) of Turkey?
Your response must be concise. -1.07. In the year 1986, what is the difference between the CO2 emissions (% of total fuel combustion) in Small states and CO2 emissions (% of total fuel combustion) in Uruguay?
Offer a terse response. -22.08. In the year 1986, what is the difference between the CO2 emissions (% of total fuel combustion) of France and CO2 emissions (% of total fuel combustion) of Turkey?
Offer a terse response. 6.45. In the year 1986, what is the difference between the CO2 emissions (% of total fuel combustion) of France and CO2 emissions (% of total fuel combustion) of Uruguay?
Offer a terse response. -14.57. In the year 1986, what is the difference between the CO2 emissions (% of total fuel combustion) in Turkey and CO2 emissions (% of total fuel combustion) in Uruguay?
Make the answer very short. -21.02. In the year 1987, what is the difference between the CO2 emissions (% of total fuel combustion) of Small states and CO2 emissions (% of total fuel combustion) of France?
Your answer should be very brief. -9.33. In the year 1987, what is the difference between the CO2 emissions (% of total fuel combustion) in Small states and CO2 emissions (% of total fuel combustion) in Turkey?
Provide a short and direct response. -2.19. In the year 1987, what is the difference between the CO2 emissions (% of total fuel combustion) in Small states and CO2 emissions (% of total fuel combustion) in Uruguay?
Provide a succinct answer. -19.33. In the year 1987, what is the difference between the CO2 emissions (% of total fuel combustion) of France and CO2 emissions (% of total fuel combustion) of Turkey?
Keep it short and to the point. 7.15. In the year 1987, what is the difference between the CO2 emissions (% of total fuel combustion) of France and CO2 emissions (% of total fuel combustion) of Uruguay?
Make the answer very short. -10. In the year 1987, what is the difference between the CO2 emissions (% of total fuel combustion) of Turkey and CO2 emissions (% of total fuel combustion) of Uruguay?
Your response must be concise. -17.15. In the year 1988, what is the difference between the CO2 emissions (% of total fuel combustion) of Small states and CO2 emissions (% of total fuel combustion) of France?
Your response must be concise. -13.95. In the year 1988, what is the difference between the CO2 emissions (% of total fuel combustion) in Small states and CO2 emissions (% of total fuel combustion) in Turkey?
Make the answer very short. -6.18. In the year 1988, what is the difference between the CO2 emissions (% of total fuel combustion) of Small states and CO2 emissions (% of total fuel combustion) of Uruguay?
Your response must be concise. -14.48. In the year 1988, what is the difference between the CO2 emissions (% of total fuel combustion) in France and CO2 emissions (% of total fuel combustion) in Turkey?
Your answer should be very brief. 7.77. In the year 1988, what is the difference between the CO2 emissions (% of total fuel combustion) in France and CO2 emissions (% of total fuel combustion) in Uruguay?
Offer a terse response. -0.54. In the year 1988, what is the difference between the CO2 emissions (% of total fuel combustion) in Turkey and CO2 emissions (% of total fuel combustion) in Uruguay?
Provide a succinct answer. -8.3. In the year 1989, what is the difference between the CO2 emissions (% of total fuel combustion) of Small states and CO2 emissions (% of total fuel combustion) of France?
Provide a succinct answer. -13.84. In the year 1989, what is the difference between the CO2 emissions (% of total fuel combustion) in Small states and CO2 emissions (% of total fuel combustion) in Turkey?
Keep it short and to the point. -4.75. In the year 1989, what is the difference between the CO2 emissions (% of total fuel combustion) of Small states and CO2 emissions (% of total fuel combustion) of Uruguay?
Offer a very short reply. -14.25. In the year 1989, what is the difference between the CO2 emissions (% of total fuel combustion) of France and CO2 emissions (% of total fuel combustion) of Turkey?
Provide a succinct answer. 9.09. In the year 1989, what is the difference between the CO2 emissions (% of total fuel combustion) of France and CO2 emissions (% of total fuel combustion) of Uruguay?
Provide a short and direct response. -0.41. In the year 1989, what is the difference between the CO2 emissions (% of total fuel combustion) of Turkey and CO2 emissions (% of total fuel combustion) of Uruguay?
Make the answer very short. -9.5. What is the ratio of the CO2 emissions (% of total fuel combustion) in Small states in 1982 to that in 1983?
Provide a short and direct response. 1.02. What is the ratio of the CO2 emissions (% of total fuel combustion) of France in 1982 to that in 1983?
Your response must be concise. 0.95. What is the ratio of the CO2 emissions (% of total fuel combustion) of Turkey in 1982 to that in 1983?
Provide a succinct answer. 1.03. What is the ratio of the CO2 emissions (% of total fuel combustion) in Uruguay in 1982 to that in 1983?
Offer a very short reply. 0.85. What is the ratio of the CO2 emissions (% of total fuel combustion) of Small states in 1982 to that in 1984?
Provide a succinct answer. 1.05. What is the ratio of the CO2 emissions (% of total fuel combustion) in France in 1982 to that in 1984?
Give a very brief answer. 0.91. What is the ratio of the CO2 emissions (% of total fuel combustion) of Turkey in 1982 to that in 1984?
Give a very brief answer. 1.07. What is the ratio of the CO2 emissions (% of total fuel combustion) in Uruguay in 1982 to that in 1984?
Offer a terse response. 0.84. What is the ratio of the CO2 emissions (% of total fuel combustion) of Small states in 1982 to that in 1985?
Provide a short and direct response. 1.02. What is the ratio of the CO2 emissions (% of total fuel combustion) in France in 1982 to that in 1985?
Your response must be concise. 0.89. What is the ratio of the CO2 emissions (% of total fuel combustion) in Turkey in 1982 to that in 1985?
Give a very brief answer. 1.12. What is the ratio of the CO2 emissions (% of total fuel combustion) of Uruguay in 1982 to that in 1985?
Your answer should be compact. 0.81. What is the ratio of the CO2 emissions (% of total fuel combustion) of Small states in 1982 to that in 1986?
Give a very brief answer. 0.93. What is the ratio of the CO2 emissions (% of total fuel combustion) in France in 1982 to that in 1986?
Your answer should be very brief. 0.82. What is the ratio of the CO2 emissions (% of total fuel combustion) of Turkey in 1982 to that in 1986?
Your response must be concise. 1.08. What is the ratio of the CO2 emissions (% of total fuel combustion) of Uruguay in 1982 to that in 1986?
Give a very brief answer. 0.8. What is the ratio of the CO2 emissions (% of total fuel combustion) of Small states in 1982 to that in 1987?
Give a very brief answer. 0.96. What is the ratio of the CO2 emissions (% of total fuel combustion) of France in 1982 to that in 1987?
Offer a very short reply. 0.78. What is the ratio of the CO2 emissions (% of total fuel combustion) of Turkey in 1982 to that in 1987?
Keep it short and to the point. 1.05. What is the ratio of the CO2 emissions (% of total fuel combustion) of Uruguay in 1982 to that in 1987?
Your answer should be compact. 0.86. What is the ratio of the CO2 emissions (% of total fuel combustion) of Small states in 1982 to that in 1988?
Give a very brief answer. 1.1. What is the ratio of the CO2 emissions (% of total fuel combustion) in France in 1982 to that in 1988?
Offer a very short reply. 0.73. What is the ratio of the CO2 emissions (% of total fuel combustion) in Uruguay in 1982 to that in 1988?
Provide a succinct answer. 1.07. What is the ratio of the CO2 emissions (% of total fuel combustion) of Small states in 1982 to that in 1989?
Keep it short and to the point. 1.14. What is the ratio of the CO2 emissions (% of total fuel combustion) in France in 1982 to that in 1989?
Your response must be concise. 0.74. What is the ratio of the CO2 emissions (% of total fuel combustion) in Turkey in 1982 to that in 1989?
Offer a terse response. 1.08. What is the ratio of the CO2 emissions (% of total fuel combustion) in Uruguay in 1982 to that in 1989?
Provide a short and direct response. 1.09. What is the ratio of the CO2 emissions (% of total fuel combustion) of Small states in 1983 to that in 1984?
Offer a terse response. 1.03. What is the ratio of the CO2 emissions (% of total fuel combustion) of France in 1983 to that in 1984?
Make the answer very short. 0.95. What is the ratio of the CO2 emissions (% of total fuel combustion) in Turkey in 1983 to that in 1984?
Ensure brevity in your answer.  1.04. What is the ratio of the CO2 emissions (% of total fuel combustion) of Uruguay in 1983 to that in 1984?
Give a very brief answer. 0.99. What is the ratio of the CO2 emissions (% of total fuel combustion) in Small states in 1983 to that in 1985?
Give a very brief answer. 1. What is the ratio of the CO2 emissions (% of total fuel combustion) in France in 1983 to that in 1985?
Provide a short and direct response. 0.93. What is the ratio of the CO2 emissions (% of total fuel combustion) in Turkey in 1983 to that in 1985?
Offer a very short reply. 1.09. What is the ratio of the CO2 emissions (% of total fuel combustion) in Uruguay in 1983 to that in 1985?
Make the answer very short. 0.95. What is the ratio of the CO2 emissions (% of total fuel combustion) of Small states in 1983 to that in 1986?
Give a very brief answer. 0.92. What is the ratio of the CO2 emissions (% of total fuel combustion) of France in 1983 to that in 1986?
Offer a terse response. 0.86. What is the ratio of the CO2 emissions (% of total fuel combustion) of Turkey in 1983 to that in 1986?
Offer a terse response. 1.06. What is the ratio of the CO2 emissions (% of total fuel combustion) in Uruguay in 1983 to that in 1986?
Give a very brief answer. 0.94. What is the ratio of the CO2 emissions (% of total fuel combustion) of Small states in 1983 to that in 1987?
Your answer should be very brief. 0.94. What is the ratio of the CO2 emissions (% of total fuel combustion) in France in 1983 to that in 1987?
Offer a terse response. 0.82. What is the ratio of the CO2 emissions (% of total fuel combustion) of Turkey in 1983 to that in 1987?
Make the answer very short. 1.02. What is the ratio of the CO2 emissions (% of total fuel combustion) of Uruguay in 1983 to that in 1987?
Offer a terse response. 1.01. What is the ratio of the CO2 emissions (% of total fuel combustion) of Small states in 1983 to that in 1988?
Offer a terse response. 1.08. What is the ratio of the CO2 emissions (% of total fuel combustion) of France in 1983 to that in 1988?
Make the answer very short. 0.77. What is the ratio of the CO2 emissions (% of total fuel combustion) in Turkey in 1983 to that in 1988?
Give a very brief answer. 0.97. What is the ratio of the CO2 emissions (% of total fuel combustion) of Uruguay in 1983 to that in 1988?
Make the answer very short. 1.25. What is the ratio of the CO2 emissions (% of total fuel combustion) of Small states in 1983 to that in 1989?
Your answer should be compact. 1.12. What is the ratio of the CO2 emissions (% of total fuel combustion) in France in 1983 to that in 1989?
Your answer should be very brief. 0.78. What is the ratio of the CO2 emissions (% of total fuel combustion) in Turkey in 1983 to that in 1989?
Offer a terse response. 1.05. What is the ratio of the CO2 emissions (% of total fuel combustion) of Uruguay in 1983 to that in 1989?
Give a very brief answer. 1.28. What is the ratio of the CO2 emissions (% of total fuel combustion) of Small states in 1984 to that in 1985?
Give a very brief answer. 0.97. What is the ratio of the CO2 emissions (% of total fuel combustion) of France in 1984 to that in 1985?
Provide a succinct answer. 0.98. What is the ratio of the CO2 emissions (% of total fuel combustion) of Turkey in 1984 to that in 1985?
Provide a short and direct response. 1.05. What is the ratio of the CO2 emissions (% of total fuel combustion) of Uruguay in 1984 to that in 1985?
Offer a terse response. 0.97. What is the ratio of the CO2 emissions (% of total fuel combustion) of Small states in 1984 to that in 1986?
Provide a succinct answer. 0.89. What is the ratio of the CO2 emissions (% of total fuel combustion) in France in 1984 to that in 1986?
Your answer should be very brief. 0.9. What is the ratio of the CO2 emissions (% of total fuel combustion) in Turkey in 1984 to that in 1986?
Offer a very short reply. 1.01. What is the ratio of the CO2 emissions (% of total fuel combustion) in Uruguay in 1984 to that in 1986?
Give a very brief answer. 0.95. What is the ratio of the CO2 emissions (% of total fuel combustion) in Small states in 1984 to that in 1987?
Your response must be concise. 0.91. What is the ratio of the CO2 emissions (% of total fuel combustion) of France in 1984 to that in 1987?
Keep it short and to the point. 0.86. What is the ratio of the CO2 emissions (% of total fuel combustion) in Turkey in 1984 to that in 1987?
Ensure brevity in your answer.  0.98. What is the ratio of the CO2 emissions (% of total fuel combustion) of Uruguay in 1984 to that in 1987?
Your response must be concise. 1.03. What is the ratio of the CO2 emissions (% of total fuel combustion) in Small states in 1984 to that in 1988?
Your response must be concise. 1.05. What is the ratio of the CO2 emissions (% of total fuel combustion) of France in 1984 to that in 1988?
Give a very brief answer. 0.81. What is the ratio of the CO2 emissions (% of total fuel combustion) of Turkey in 1984 to that in 1988?
Offer a terse response. 0.93. What is the ratio of the CO2 emissions (% of total fuel combustion) in Uruguay in 1984 to that in 1988?
Provide a short and direct response. 1.27. What is the ratio of the CO2 emissions (% of total fuel combustion) in Small states in 1984 to that in 1989?
Keep it short and to the point. 1.08. What is the ratio of the CO2 emissions (% of total fuel combustion) of France in 1984 to that in 1989?
Provide a succinct answer. 0.82. What is the ratio of the CO2 emissions (% of total fuel combustion) in Turkey in 1984 to that in 1989?
Provide a short and direct response. 1.01. What is the ratio of the CO2 emissions (% of total fuel combustion) of Uruguay in 1984 to that in 1989?
Your answer should be compact. 1.3. What is the ratio of the CO2 emissions (% of total fuel combustion) of Small states in 1985 to that in 1986?
Make the answer very short. 0.92. What is the ratio of the CO2 emissions (% of total fuel combustion) in France in 1985 to that in 1986?
Your response must be concise. 0.92. What is the ratio of the CO2 emissions (% of total fuel combustion) of Turkey in 1985 to that in 1986?
Your response must be concise. 0.97. What is the ratio of the CO2 emissions (% of total fuel combustion) of Uruguay in 1985 to that in 1986?
Your answer should be very brief. 0.98. What is the ratio of the CO2 emissions (% of total fuel combustion) of Small states in 1985 to that in 1987?
Ensure brevity in your answer.  0.94. What is the ratio of the CO2 emissions (% of total fuel combustion) in France in 1985 to that in 1987?
Your answer should be compact. 0.88. What is the ratio of the CO2 emissions (% of total fuel combustion) of Turkey in 1985 to that in 1987?
Provide a short and direct response. 0.94. What is the ratio of the CO2 emissions (% of total fuel combustion) in Uruguay in 1985 to that in 1987?
Your answer should be very brief. 1.06. What is the ratio of the CO2 emissions (% of total fuel combustion) of Small states in 1985 to that in 1988?
Provide a short and direct response. 1.08. What is the ratio of the CO2 emissions (% of total fuel combustion) in France in 1985 to that in 1988?
Keep it short and to the point. 0.82. What is the ratio of the CO2 emissions (% of total fuel combustion) in Turkey in 1985 to that in 1988?
Offer a very short reply. 0.88. What is the ratio of the CO2 emissions (% of total fuel combustion) in Uruguay in 1985 to that in 1988?
Make the answer very short. 1.31. What is the ratio of the CO2 emissions (% of total fuel combustion) in Small states in 1985 to that in 1989?
Give a very brief answer. 1.12. What is the ratio of the CO2 emissions (% of total fuel combustion) in France in 1985 to that in 1989?
Make the answer very short. 0.84. What is the ratio of the CO2 emissions (% of total fuel combustion) in Turkey in 1985 to that in 1989?
Provide a short and direct response. 0.96. What is the ratio of the CO2 emissions (% of total fuel combustion) of Uruguay in 1985 to that in 1989?
Keep it short and to the point. 1.35. What is the ratio of the CO2 emissions (% of total fuel combustion) of Small states in 1986 to that in 1987?
Make the answer very short. 1.02. What is the ratio of the CO2 emissions (% of total fuel combustion) in France in 1986 to that in 1987?
Your response must be concise. 0.95. What is the ratio of the CO2 emissions (% of total fuel combustion) in Turkey in 1986 to that in 1987?
Your answer should be compact. 0.97. What is the ratio of the CO2 emissions (% of total fuel combustion) in Uruguay in 1986 to that in 1987?
Provide a succinct answer. 1.08. What is the ratio of the CO2 emissions (% of total fuel combustion) in Small states in 1986 to that in 1988?
Provide a short and direct response. 1.18. What is the ratio of the CO2 emissions (% of total fuel combustion) of France in 1986 to that in 1988?
Make the answer very short. 0.89. What is the ratio of the CO2 emissions (% of total fuel combustion) of Turkey in 1986 to that in 1988?
Offer a very short reply. 0.91. What is the ratio of the CO2 emissions (% of total fuel combustion) in Uruguay in 1986 to that in 1988?
Your answer should be compact. 1.34. What is the ratio of the CO2 emissions (% of total fuel combustion) in Small states in 1986 to that in 1989?
Keep it short and to the point. 1.22. What is the ratio of the CO2 emissions (% of total fuel combustion) of France in 1986 to that in 1989?
Keep it short and to the point. 0.91. What is the ratio of the CO2 emissions (% of total fuel combustion) of Turkey in 1986 to that in 1989?
Ensure brevity in your answer.  1. What is the ratio of the CO2 emissions (% of total fuel combustion) in Uruguay in 1986 to that in 1989?
Provide a short and direct response. 1.37. What is the ratio of the CO2 emissions (% of total fuel combustion) in Small states in 1987 to that in 1988?
Your answer should be compact. 1.16. What is the ratio of the CO2 emissions (% of total fuel combustion) in France in 1987 to that in 1988?
Ensure brevity in your answer.  0.94. What is the ratio of the CO2 emissions (% of total fuel combustion) in Turkey in 1987 to that in 1988?
Your answer should be very brief. 0.94. What is the ratio of the CO2 emissions (% of total fuel combustion) of Uruguay in 1987 to that in 1988?
Make the answer very short. 1.24. What is the ratio of the CO2 emissions (% of total fuel combustion) in Small states in 1987 to that in 1989?
Your answer should be compact. 1.19. What is the ratio of the CO2 emissions (% of total fuel combustion) in France in 1987 to that in 1989?
Provide a succinct answer. 0.96. What is the ratio of the CO2 emissions (% of total fuel combustion) of Turkey in 1987 to that in 1989?
Keep it short and to the point. 1.03. What is the ratio of the CO2 emissions (% of total fuel combustion) in Uruguay in 1987 to that in 1989?
Offer a very short reply. 1.27. What is the ratio of the CO2 emissions (% of total fuel combustion) of Small states in 1988 to that in 1989?
Offer a terse response. 1.03. What is the ratio of the CO2 emissions (% of total fuel combustion) in France in 1988 to that in 1989?
Give a very brief answer. 1.02. What is the ratio of the CO2 emissions (% of total fuel combustion) in Turkey in 1988 to that in 1989?
Offer a very short reply. 1.09. What is the ratio of the CO2 emissions (% of total fuel combustion) in Uruguay in 1988 to that in 1989?
Provide a succinct answer. 1.02. What is the difference between the highest and the second highest CO2 emissions (% of total fuel combustion) of Small states?
Your response must be concise. 0.44. What is the difference between the highest and the second highest CO2 emissions (% of total fuel combustion) in France?
Offer a very short reply. 0.6. What is the difference between the highest and the second highest CO2 emissions (% of total fuel combustion) of Turkey?
Provide a succinct answer. 0.19. What is the difference between the highest and the second highest CO2 emissions (% of total fuel combustion) in Uruguay?
Ensure brevity in your answer.  0.73. What is the difference between the highest and the lowest CO2 emissions (% of total fuel combustion) in Small states?
Ensure brevity in your answer.  3.6. What is the difference between the highest and the lowest CO2 emissions (% of total fuel combustion) of France?
Make the answer very short. 8.4. What is the difference between the highest and the lowest CO2 emissions (% of total fuel combustion) of Turkey?
Provide a succinct answer. 2.74. What is the difference between the highest and the lowest CO2 emissions (% of total fuel combustion) in Uruguay?
Offer a terse response. 11.43. 